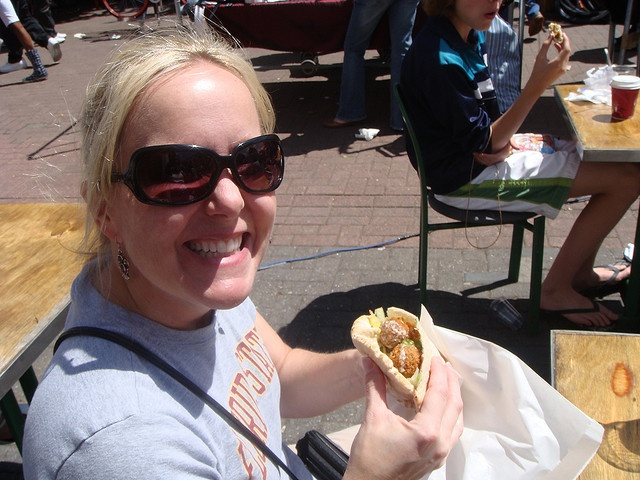Describe the objects in this image and their specific colors. I can see people in lavender, maroon, gray, and black tones, people in lavender, black, maroon, gray, and white tones, dining table in lavender, tan, and gray tones, dining table in lavender and tan tones, and dining table in lavender, tan, lightgray, black, and maroon tones in this image. 